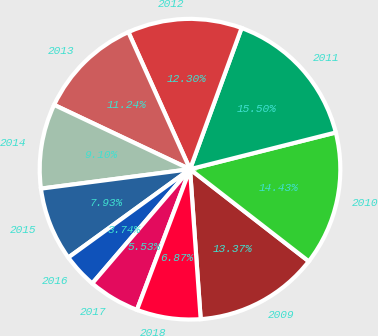<chart> <loc_0><loc_0><loc_500><loc_500><pie_chart><fcel>2009<fcel>2010<fcel>2011<fcel>2012<fcel>2013<fcel>2014<fcel>2015<fcel>2016<fcel>2017<fcel>2018<nl><fcel>13.37%<fcel>14.43%<fcel>15.5%<fcel>12.3%<fcel>11.24%<fcel>9.1%<fcel>7.93%<fcel>3.74%<fcel>5.53%<fcel>6.87%<nl></chart> 